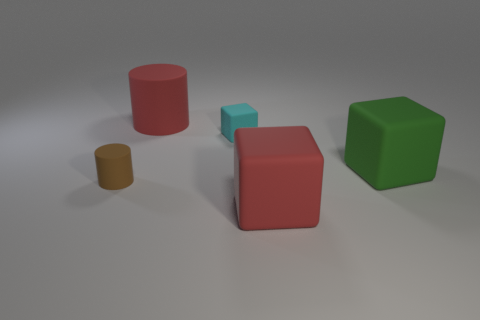What materials do the objects in the image resemble? The objects in the image mimic various materials. The red cylinder has a rubber-like texture, which is matte and non-reflective. The smaller brown cylinder looks like it may be made of either a matte plastic or wood due to its dull finish. The green cube has a solid, velvety appearance, suggesting that it could be made of a matte plastic. Last, the red and cyan cubes have a matte finish, indicating that they could be made of plastic or perhaps even painted wood. 